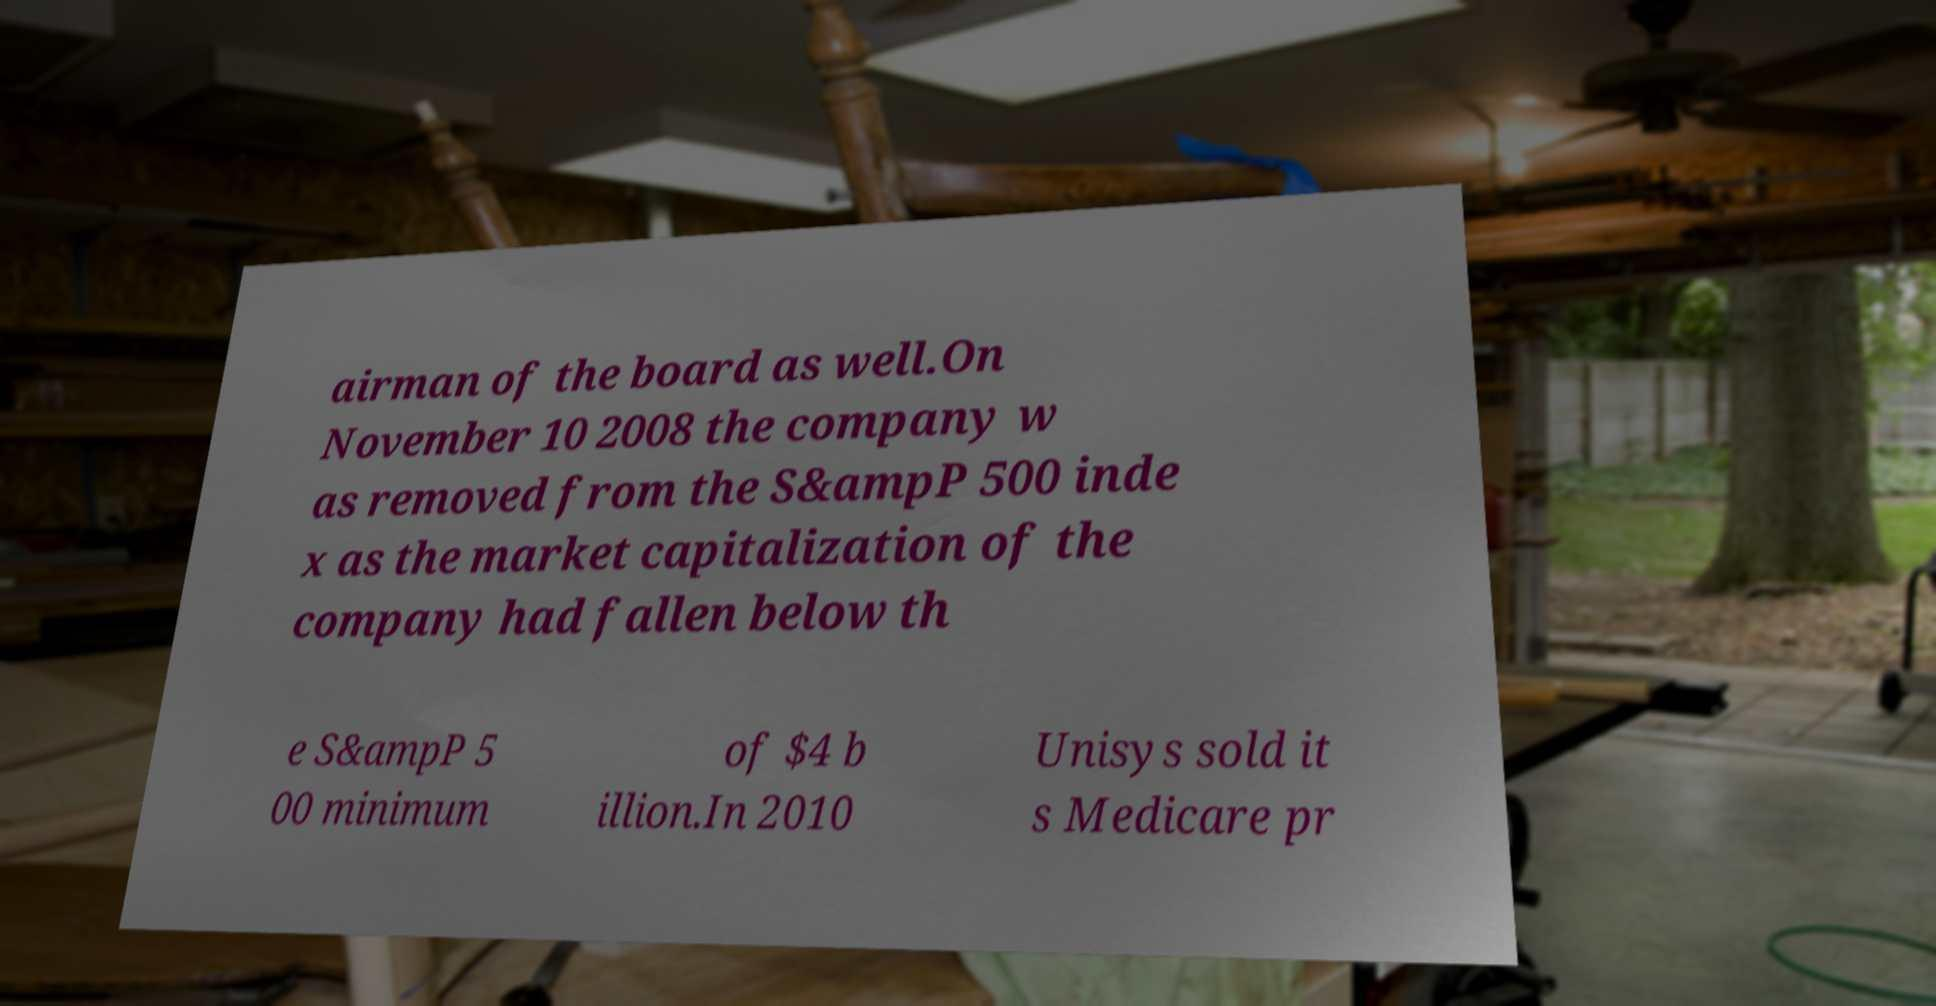Please read and relay the text visible in this image. What does it say? airman of the board as well.On November 10 2008 the company w as removed from the S&ampP 500 inde x as the market capitalization of the company had fallen below th e S&ampP 5 00 minimum of $4 b illion.In 2010 Unisys sold it s Medicare pr 